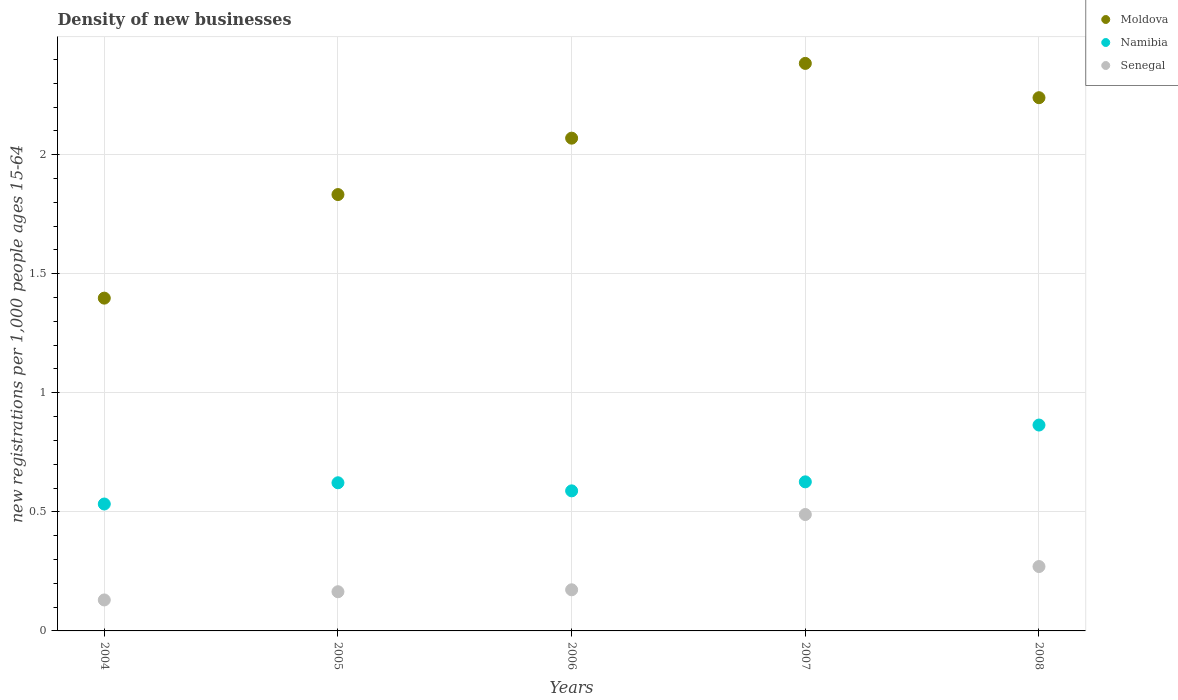How many different coloured dotlines are there?
Make the answer very short. 3. Is the number of dotlines equal to the number of legend labels?
Make the answer very short. Yes. What is the number of new registrations in Senegal in 2004?
Provide a short and direct response. 0.13. Across all years, what is the maximum number of new registrations in Namibia?
Ensure brevity in your answer.  0.86. Across all years, what is the minimum number of new registrations in Senegal?
Your answer should be compact. 0.13. In which year was the number of new registrations in Senegal maximum?
Make the answer very short. 2007. In which year was the number of new registrations in Senegal minimum?
Your response must be concise. 2004. What is the total number of new registrations in Senegal in the graph?
Give a very brief answer. 1.23. What is the difference between the number of new registrations in Moldova in 2004 and that in 2005?
Offer a very short reply. -0.43. What is the difference between the number of new registrations in Senegal in 2006 and the number of new registrations in Namibia in 2007?
Make the answer very short. -0.45. What is the average number of new registrations in Namibia per year?
Make the answer very short. 0.65. In the year 2004, what is the difference between the number of new registrations in Senegal and number of new registrations in Moldova?
Give a very brief answer. -1.27. What is the ratio of the number of new registrations in Moldova in 2005 to that in 2007?
Provide a succinct answer. 0.77. What is the difference between the highest and the second highest number of new registrations in Moldova?
Ensure brevity in your answer.  0.14. What is the difference between the highest and the lowest number of new registrations in Moldova?
Ensure brevity in your answer.  0.99. Is it the case that in every year, the sum of the number of new registrations in Moldova and number of new registrations in Senegal  is greater than the number of new registrations in Namibia?
Offer a very short reply. Yes. Does the number of new registrations in Moldova monotonically increase over the years?
Keep it short and to the point. No. Is the number of new registrations in Moldova strictly greater than the number of new registrations in Senegal over the years?
Provide a short and direct response. Yes. How many dotlines are there?
Provide a short and direct response. 3. What is the difference between two consecutive major ticks on the Y-axis?
Offer a terse response. 0.5. Are the values on the major ticks of Y-axis written in scientific E-notation?
Keep it short and to the point. No. Does the graph contain any zero values?
Ensure brevity in your answer.  No. What is the title of the graph?
Your answer should be compact. Density of new businesses. What is the label or title of the Y-axis?
Offer a terse response. New registrations per 1,0 people ages 15-64. What is the new registrations per 1,000 people ages 15-64 of Moldova in 2004?
Provide a short and direct response. 1.4. What is the new registrations per 1,000 people ages 15-64 in Namibia in 2004?
Keep it short and to the point. 0.53. What is the new registrations per 1,000 people ages 15-64 of Senegal in 2004?
Provide a short and direct response. 0.13. What is the new registrations per 1,000 people ages 15-64 of Moldova in 2005?
Your response must be concise. 1.83. What is the new registrations per 1,000 people ages 15-64 of Namibia in 2005?
Your response must be concise. 0.62. What is the new registrations per 1,000 people ages 15-64 of Senegal in 2005?
Provide a short and direct response. 0.16. What is the new registrations per 1,000 people ages 15-64 in Moldova in 2006?
Your response must be concise. 2.07. What is the new registrations per 1,000 people ages 15-64 of Namibia in 2006?
Ensure brevity in your answer.  0.59. What is the new registrations per 1,000 people ages 15-64 of Senegal in 2006?
Keep it short and to the point. 0.17. What is the new registrations per 1,000 people ages 15-64 in Moldova in 2007?
Provide a short and direct response. 2.38. What is the new registrations per 1,000 people ages 15-64 of Namibia in 2007?
Ensure brevity in your answer.  0.63. What is the new registrations per 1,000 people ages 15-64 in Senegal in 2007?
Make the answer very short. 0.49. What is the new registrations per 1,000 people ages 15-64 in Moldova in 2008?
Your response must be concise. 2.24. What is the new registrations per 1,000 people ages 15-64 in Namibia in 2008?
Make the answer very short. 0.86. What is the new registrations per 1,000 people ages 15-64 of Senegal in 2008?
Make the answer very short. 0.27. Across all years, what is the maximum new registrations per 1,000 people ages 15-64 in Moldova?
Keep it short and to the point. 2.38. Across all years, what is the maximum new registrations per 1,000 people ages 15-64 of Namibia?
Provide a succinct answer. 0.86. Across all years, what is the maximum new registrations per 1,000 people ages 15-64 in Senegal?
Offer a terse response. 0.49. Across all years, what is the minimum new registrations per 1,000 people ages 15-64 of Moldova?
Provide a succinct answer. 1.4. Across all years, what is the minimum new registrations per 1,000 people ages 15-64 in Namibia?
Make the answer very short. 0.53. Across all years, what is the minimum new registrations per 1,000 people ages 15-64 in Senegal?
Provide a short and direct response. 0.13. What is the total new registrations per 1,000 people ages 15-64 of Moldova in the graph?
Your answer should be compact. 9.92. What is the total new registrations per 1,000 people ages 15-64 of Namibia in the graph?
Your answer should be compact. 3.23. What is the total new registrations per 1,000 people ages 15-64 of Senegal in the graph?
Your answer should be compact. 1.23. What is the difference between the new registrations per 1,000 people ages 15-64 in Moldova in 2004 and that in 2005?
Offer a very short reply. -0.43. What is the difference between the new registrations per 1,000 people ages 15-64 in Namibia in 2004 and that in 2005?
Make the answer very short. -0.09. What is the difference between the new registrations per 1,000 people ages 15-64 of Senegal in 2004 and that in 2005?
Keep it short and to the point. -0.03. What is the difference between the new registrations per 1,000 people ages 15-64 in Moldova in 2004 and that in 2006?
Your answer should be very brief. -0.67. What is the difference between the new registrations per 1,000 people ages 15-64 in Namibia in 2004 and that in 2006?
Your answer should be compact. -0.06. What is the difference between the new registrations per 1,000 people ages 15-64 in Senegal in 2004 and that in 2006?
Ensure brevity in your answer.  -0.04. What is the difference between the new registrations per 1,000 people ages 15-64 in Moldova in 2004 and that in 2007?
Keep it short and to the point. -0.99. What is the difference between the new registrations per 1,000 people ages 15-64 of Namibia in 2004 and that in 2007?
Offer a very short reply. -0.09. What is the difference between the new registrations per 1,000 people ages 15-64 of Senegal in 2004 and that in 2007?
Your response must be concise. -0.36. What is the difference between the new registrations per 1,000 people ages 15-64 of Moldova in 2004 and that in 2008?
Provide a short and direct response. -0.84. What is the difference between the new registrations per 1,000 people ages 15-64 in Namibia in 2004 and that in 2008?
Keep it short and to the point. -0.33. What is the difference between the new registrations per 1,000 people ages 15-64 of Senegal in 2004 and that in 2008?
Offer a terse response. -0.14. What is the difference between the new registrations per 1,000 people ages 15-64 of Moldova in 2005 and that in 2006?
Give a very brief answer. -0.24. What is the difference between the new registrations per 1,000 people ages 15-64 in Namibia in 2005 and that in 2006?
Keep it short and to the point. 0.03. What is the difference between the new registrations per 1,000 people ages 15-64 in Senegal in 2005 and that in 2006?
Give a very brief answer. -0.01. What is the difference between the new registrations per 1,000 people ages 15-64 of Moldova in 2005 and that in 2007?
Make the answer very short. -0.55. What is the difference between the new registrations per 1,000 people ages 15-64 in Namibia in 2005 and that in 2007?
Give a very brief answer. -0. What is the difference between the new registrations per 1,000 people ages 15-64 in Senegal in 2005 and that in 2007?
Your answer should be compact. -0.32. What is the difference between the new registrations per 1,000 people ages 15-64 of Moldova in 2005 and that in 2008?
Your answer should be compact. -0.41. What is the difference between the new registrations per 1,000 people ages 15-64 in Namibia in 2005 and that in 2008?
Offer a very short reply. -0.24. What is the difference between the new registrations per 1,000 people ages 15-64 in Senegal in 2005 and that in 2008?
Give a very brief answer. -0.11. What is the difference between the new registrations per 1,000 people ages 15-64 in Moldova in 2006 and that in 2007?
Your response must be concise. -0.31. What is the difference between the new registrations per 1,000 people ages 15-64 of Namibia in 2006 and that in 2007?
Make the answer very short. -0.04. What is the difference between the new registrations per 1,000 people ages 15-64 of Senegal in 2006 and that in 2007?
Keep it short and to the point. -0.32. What is the difference between the new registrations per 1,000 people ages 15-64 of Moldova in 2006 and that in 2008?
Provide a succinct answer. -0.17. What is the difference between the new registrations per 1,000 people ages 15-64 in Namibia in 2006 and that in 2008?
Give a very brief answer. -0.28. What is the difference between the new registrations per 1,000 people ages 15-64 in Senegal in 2006 and that in 2008?
Give a very brief answer. -0.1. What is the difference between the new registrations per 1,000 people ages 15-64 of Moldova in 2007 and that in 2008?
Give a very brief answer. 0.14. What is the difference between the new registrations per 1,000 people ages 15-64 of Namibia in 2007 and that in 2008?
Keep it short and to the point. -0.24. What is the difference between the new registrations per 1,000 people ages 15-64 in Senegal in 2007 and that in 2008?
Provide a succinct answer. 0.22. What is the difference between the new registrations per 1,000 people ages 15-64 of Moldova in 2004 and the new registrations per 1,000 people ages 15-64 of Namibia in 2005?
Your response must be concise. 0.78. What is the difference between the new registrations per 1,000 people ages 15-64 of Moldova in 2004 and the new registrations per 1,000 people ages 15-64 of Senegal in 2005?
Give a very brief answer. 1.23. What is the difference between the new registrations per 1,000 people ages 15-64 in Namibia in 2004 and the new registrations per 1,000 people ages 15-64 in Senegal in 2005?
Offer a terse response. 0.37. What is the difference between the new registrations per 1,000 people ages 15-64 in Moldova in 2004 and the new registrations per 1,000 people ages 15-64 in Namibia in 2006?
Offer a very short reply. 0.81. What is the difference between the new registrations per 1,000 people ages 15-64 in Moldova in 2004 and the new registrations per 1,000 people ages 15-64 in Senegal in 2006?
Offer a terse response. 1.22. What is the difference between the new registrations per 1,000 people ages 15-64 in Namibia in 2004 and the new registrations per 1,000 people ages 15-64 in Senegal in 2006?
Your answer should be compact. 0.36. What is the difference between the new registrations per 1,000 people ages 15-64 of Moldova in 2004 and the new registrations per 1,000 people ages 15-64 of Namibia in 2007?
Offer a terse response. 0.77. What is the difference between the new registrations per 1,000 people ages 15-64 in Moldova in 2004 and the new registrations per 1,000 people ages 15-64 in Senegal in 2007?
Keep it short and to the point. 0.91. What is the difference between the new registrations per 1,000 people ages 15-64 in Namibia in 2004 and the new registrations per 1,000 people ages 15-64 in Senegal in 2007?
Your response must be concise. 0.04. What is the difference between the new registrations per 1,000 people ages 15-64 in Moldova in 2004 and the new registrations per 1,000 people ages 15-64 in Namibia in 2008?
Your answer should be very brief. 0.53. What is the difference between the new registrations per 1,000 people ages 15-64 in Moldova in 2004 and the new registrations per 1,000 people ages 15-64 in Senegal in 2008?
Provide a short and direct response. 1.13. What is the difference between the new registrations per 1,000 people ages 15-64 of Namibia in 2004 and the new registrations per 1,000 people ages 15-64 of Senegal in 2008?
Keep it short and to the point. 0.26. What is the difference between the new registrations per 1,000 people ages 15-64 in Moldova in 2005 and the new registrations per 1,000 people ages 15-64 in Namibia in 2006?
Keep it short and to the point. 1.24. What is the difference between the new registrations per 1,000 people ages 15-64 in Moldova in 2005 and the new registrations per 1,000 people ages 15-64 in Senegal in 2006?
Your answer should be compact. 1.66. What is the difference between the new registrations per 1,000 people ages 15-64 in Namibia in 2005 and the new registrations per 1,000 people ages 15-64 in Senegal in 2006?
Your answer should be compact. 0.45. What is the difference between the new registrations per 1,000 people ages 15-64 in Moldova in 2005 and the new registrations per 1,000 people ages 15-64 in Namibia in 2007?
Keep it short and to the point. 1.21. What is the difference between the new registrations per 1,000 people ages 15-64 of Moldova in 2005 and the new registrations per 1,000 people ages 15-64 of Senegal in 2007?
Provide a succinct answer. 1.34. What is the difference between the new registrations per 1,000 people ages 15-64 of Namibia in 2005 and the new registrations per 1,000 people ages 15-64 of Senegal in 2007?
Your response must be concise. 0.13. What is the difference between the new registrations per 1,000 people ages 15-64 of Moldova in 2005 and the new registrations per 1,000 people ages 15-64 of Namibia in 2008?
Ensure brevity in your answer.  0.97. What is the difference between the new registrations per 1,000 people ages 15-64 in Moldova in 2005 and the new registrations per 1,000 people ages 15-64 in Senegal in 2008?
Offer a terse response. 1.56. What is the difference between the new registrations per 1,000 people ages 15-64 of Namibia in 2005 and the new registrations per 1,000 people ages 15-64 of Senegal in 2008?
Give a very brief answer. 0.35. What is the difference between the new registrations per 1,000 people ages 15-64 of Moldova in 2006 and the new registrations per 1,000 people ages 15-64 of Namibia in 2007?
Provide a succinct answer. 1.44. What is the difference between the new registrations per 1,000 people ages 15-64 in Moldova in 2006 and the new registrations per 1,000 people ages 15-64 in Senegal in 2007?
Provide a short and direct response. 1.58. What is the difference between the new registrations per 1,000 people ages 15-64 in Namibia in 2006 and the new registrations per 1,000 people ages 15-64 in Senegal in 2007?
Provide a short and direct response. 0.1. What is the difference between the new registrations per 1,000 people ages 15-64 in Moldova in 2006 and the new registrations per 1,000 people ages 15-64 in Namibia in 2008?
Give a very brief answer. 1.2. What is the difference between the new registrations per 1,000 people ages 15-64 in Moldova in 2006 and the new registrations per 1,000 people ages 15-64 in Senegal in 2008?
Provide a succinct answer. 1.8. What is the difference between the new registrations per 1,000 people ages 15-64 of Namibia in 2006 and the new registrations per 1,000 people ages 15-64 of Senegal in 2008?
Provide a short and direct response. 0.32. What is the difference between the new registrations per 1,000 people ages 15-64 in Moldova in 2007 and the new registrations per 1,000 people ages 15-64 in Namibia in 2008?
Ensure brevity in your answer.  1.52. What is the difference between the new registrations per 1,000 people ages 15-64 in Moldova in 2007 and the new registrations per 1,000 people ages 15-64 in Senegal in 2008?
Your answer should be very brief. 2.11. What is the difference between the new registrations per 1,000 people ages 15-64 of Namibia in 2007 and the new registrations per 1,000 people ages 15-64 of Senegal in 2008?
Offer a terse response. 0.36. What is the average new registrations per 1,000 people ages 15-64 in Moldova per year?
Offer a very short reply. 1.98. What is the average new registrations per 1,000 people ages 15-64 of Namibia per year?
Provide a succinct answer. 0.65. What is the average new registrations per 1,000 people ages 15-64 in Senegal per year?
Your answer should be very brief. 0.25. In the year 2004, what is the difference between the new registrations per 1,000 people ages 15-64 in Moldova and new registrations per 1,000 people ages 15-64 in Namibia?
Offer a terse response. 0.86. In the year 2004, what is the difference between the new registrations per 1,000 people ages 15-64 of Moldova and new registrations per 1,000 people ages 15-64 of Senegal?
Offer a terse response. 1.27. In the year 2004, what is the difference between the new registrations per 1,000 people ages 15-64 of Namibia and new registrations per 1,000 people ages 15-64 of Senegal?
Your response must be concise. 0.4. In the year 2005, what is the difference between the new registrations per 1,000 people ages 15-64 in Moldova and new registrations per 1,000 people ages 15-64 in Namibia?
Give a very brief answer. 1.21. In the year 2005, what is the difference between the new registrations per 1,000 people ages 15-64 in Moldova and new registrations per 1,000 people ages 15-64 in Senegal?
Keep it short and to the point. 1.67. In the year 2005, what is the difference between the new registrations per 1,000 people ages 15-64 of Namibia and new registrations per 1,000 people ages 15-64 of Senegal?
Make the answer very short. 0.46. In the year 2006, what is the difference between the new registrations per 1,000 people ages 15-64 in Moldova and new registrations per 1,000 people ages 15-64 in Namibia?
Your answer should be compact. 1.48. In the year 2006, what is the difference between the new registrations per 1,000 people ages 15-64 of Moldova and new registrations per 1,000 people ages 15-64 of Senegal?
Your answer should be very brief. 1.9. In the year 2006, what is the difference between the new registrations per 1,000 people ages 15-64 of Namibia and new registrations per 1,000 people ages 15-64 of Senegal?
Your response must be concise. 0.42. In the year 2007, what is the difference between the new registrations per 1,000 people ages 15-64 of Moldova and new registrations per 1,000 people ages 15-64 of Namibia?
Keep it short and to the point. 1.76. In the year 2007, what is the difference between the new registrations per 1,000 people ages 15-64 in Moldova and new registrations per 1,000 people ages 15-64 in Senegal?
Ensure brevity in your answer.  1.89. In the year 2007, what is the difference between the new registrations per 1,000 people ages 15-64 of Namibia and new registrations per 1,000 people ages 15-64 of Senegal?
Ensure brevity in your answer.  0.14. In the year 2008, what is the difference between the new registrations per 1,000 people ages 15-64 in Moldova and new registrations per 1,000 people ages 15-64 in Namibia?
Give a very brief answer. 1.37. In the year 2008, what is the difference between the new registrations per 1,000 people ages 15-64 in Moldova and new registrations per 1,000 people ages 15-64 in Senegal?
Provide a succinct answer. 1.97. In the year 2008, what is the difference between the new registrations per 1,000 people ages 15-64 of Namibia and new registrations per 1,000 people ages 15-64 of Senegal?
Your answer should be very brief. 0.59. What is the ratio of the new registrations per 1,000 people ages 15-64 of Moldova in 2004 to that in 2005?
Offer a very short reply. 0.76. What is the ratio of the new registrations per 1,000 people ages 15-64 in Namibia in 2004 to that in 2005?
Your answer should be compact. 0.86. What is the ratio of the new registrations per 1,000 people ages 15-64 of Senegal in 2004 to that in 2005?
Your answer should be very brief. 0.79. What is the ratio of the new registrations per 1,000 people ages 15-64 in Moldova in 2004 to that in 2006?
Offer a terse response. 0.68. What is the ratio of the new registrations per 1,000 people ages 15-64 of Namibia in 2004 to that in 2006?
Your answer should be compact. 0.91. What is the ratio of the new registrations per 1,000 people ages 15-64 in Senegal in 2004 to that in 2006?
Give a very brief answer. 0.75. What is the ratio of the new registrations per 1,000 people ages 15-64 in Moldova in 2004 to that in 2007?
Provide a short and direct response. 0.59. What is the ratio of the new registrations per 1,000 people ages 15-64 of Namibia in 2004 to that in 2007?
Your answer should be compact. 0.85. What is the ratio of the new registrations per 1,000 people ages 15-64 in Senegal in 2004 to that in 2007?
Give a very brief answer. 0.27. What is the ratio of the new registrations per 1,000 people ages 15-64 in Moldova in 2004 to that in 2008?
Provide a succinct answer. 0.62. What is the ratio of the new registrations per 1,000 people ages 15-64 in Namibia in 2004 to that in 2008?
Give a very brief answer. 0.62. What is the ratio of the new registrations per 1,000 people ages 15-64 in Senegal in 2004 to that in 2008?
Provide a succinct answer. 0.48. What is the ratio of the new registrations per 1,000 people ages 15-64 in Moldova in 2005 to that in 2006?
Ensure brevity in your answer.  0.89. What is the ratio of the new registrations per 1,000 people ages 15-64 in Namibia in 2005 to that in 2006?
Your answer should be compact. 1.06. What is the ratio of the new registrations per 1,000 people ages 15-64 in Senegal in 2005 to that in 2006?
Keep it short and to the point. 0.95. What is the ratio of the new registrations per 1,000 people ages 15-64 in Moldova in 2005 to that in 2007?
Ensure brevity in your answer.  0.77. What is the ratio of the new registrations per 1,000 people ages 15-64 in Namibia in 2005 to that in 2007?
Your answer should be compact. 0.99. What is the ratio of the new registrations per 1,000 people ages 15-64 in Senegal in 2005 to that in 2007?
Your response must be concise. 0.34. What is the ratio of the new registrations per 1,000 people ages 15-64 in Moldova in 2005 to that in 2008?
Offer a very short reply. 0.82. What is the ratio of the new registrations per 1,000 people ages 15-64 in Namibia in 2005 to that in 2008?
Ensure brevity in your answer.  0.72. What is the ratio of the new registrations per 1,000 people ages 15-64 in Senegal in 2005 to that in 2008?
Give a very brief answer. 0.61. What is the ratio of the new registrations per 1,000 people ages 15-64 of Moldova in 2006 to that in 2007?
Offer a very short reply. 0.87. What is the ratio of the new registrations per 1,000 people ages 15-64 of Namibia in 2006 to that in 2007?
Give a very brief answer. 0.94. What is the ratio of the new registrations per 1,000 people ages 15-64 in Senegal in 2006 to that in 2007?
Offer a terse response. 0.35. What is the ratio of the new registrations per 1,000 people ages 15-64 of Moldova in 2006 to that in 2008?
Provide a short and direct response. 0.92. What is the ratio of the new registrations per 1,000 people ages 15-64 of Namibia in 2006 to that in 2008?
Provide a short and direct response. 0.68. What is the ratio of the new registrations per 1,000 people ages 15-64 of Senegal in 2006 to that in 2008?
Offer a very short reply. 0.64. What is the ratio of the new registrations per 1,000 people ages 15-64 of Moldova in 2007 to that in 2008?
Ensure brevity in your answer.  1.06. What is the ratio of the new registrations per 1,000 people ages 15-64 of Namibia in 2007 to that in 2008?
Your answer should be compact. 0.72. What is the ratio of the new registrations per 1,000 people ages 15-64 of Senegal in 2007 to that in 2008?
Your answer should be compact. 1.81. What is the difference between the highest and the second highest new registrations per 1,000 people ages 15-64 in Moldova?
Provide a succinct answer. 0.14. What is the difference between the highest and the second highest new registrations per 1,000 people ages 15-64 in Namibia?
Ensure brevity in your answer.  0.24. What is the difference between the highest and the second highest new registrations per 1,000 people ages 15-64 of Senegal?
Ensure brevity in your answer.  0.22. What is the difference between the highest and the lowest new registrations per 1,000 people ages 15-64 in Moldova?
Provide a succinct answer. 0.99. What is the difference between the highest and the lowest new registrations per 1,000 people ages 15-64 of Namibia?
Make the answer very short. 0.33. What is the difference between the highest and the lowest new registrations per 1,000 people ages 15-64 of Senegal?
Your answer should be compact. 0.36. 